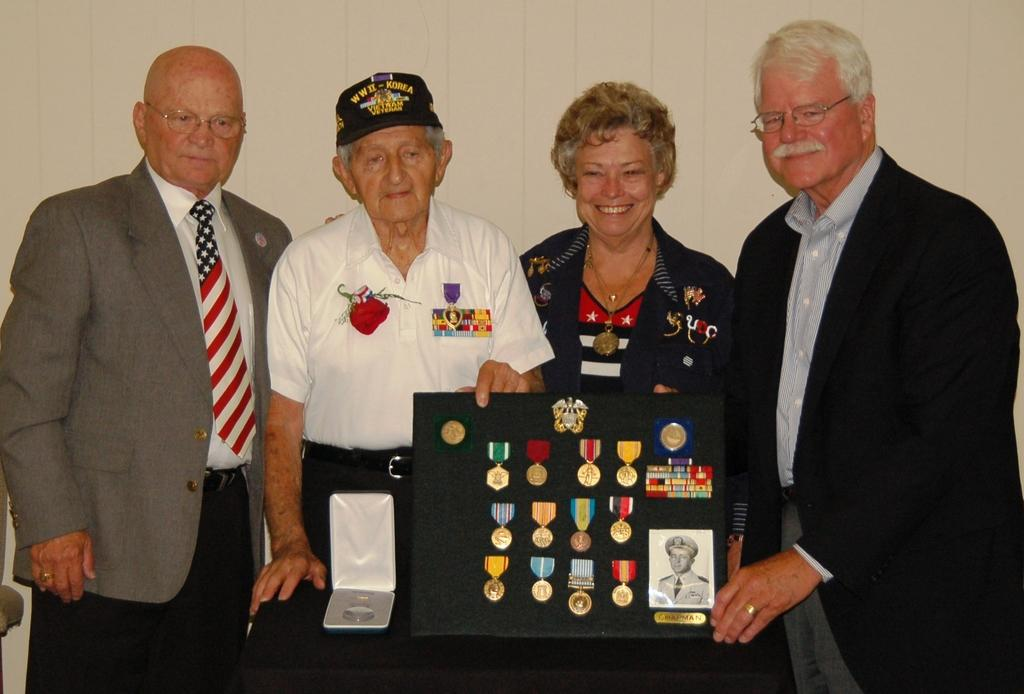What can be seen in the image involving people? There are people standing in the image. What is displayed on the board in the image? There is a board with medals and a photograph in the image. Can you describe the man's attire in the image? A man is wearing a cap in the image. What type of silk material is draped over the medals on the board? There is no silk material draped over the medals on the board in the image. What kind of metal is used to make the cord that holds the photograph on the board? There is no cord visible in the image, and therefore no metal can be identified. 